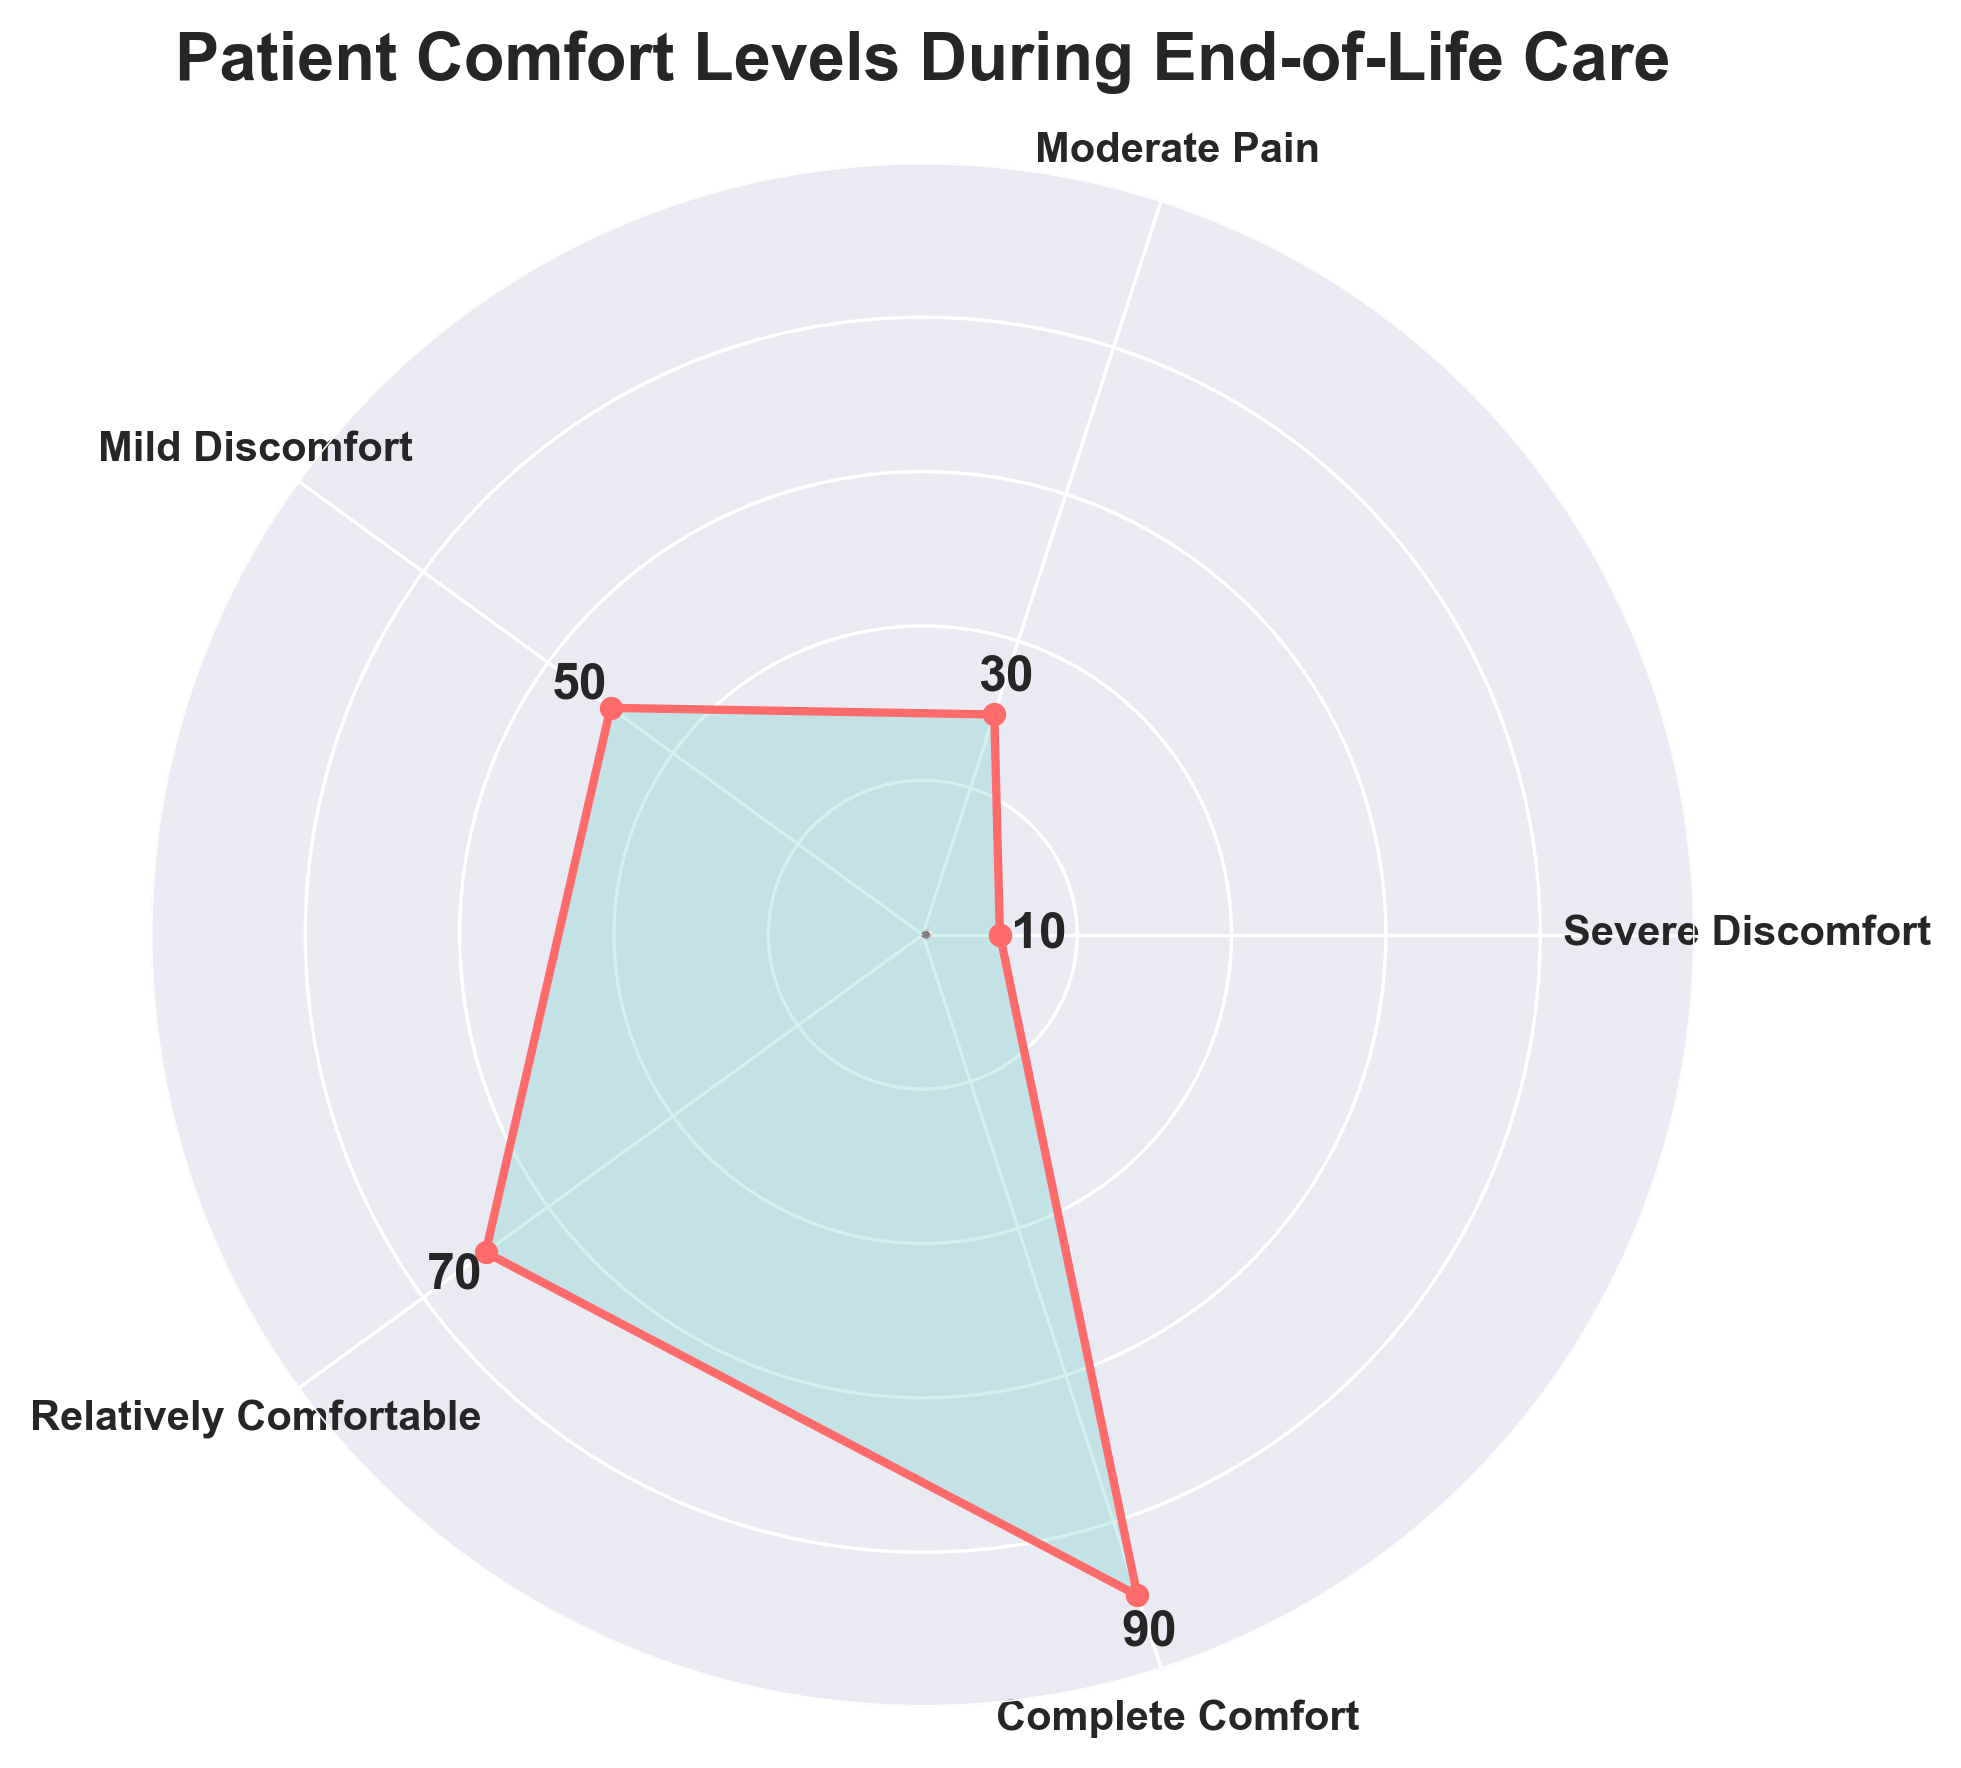What is the title of the figure? The title is usually located at or near the top of the figure. This one states "Patient Comfort Levels During End-of-Life Care".
Answer: Patient Comfort Levels During End-of-Life Care How many different comfort levels are displayed in the figure? Count the number of unique comfort levels indicated by text labels on the figure. There are five unique comfort levels.
Answer: 5 Which comfort level has the highest value? The value associated with each comfort level is displayed next to the labels. The highest value is associated with "Complete Comfort".
Answer: Complete Comfort What's the difference in value between "Severe Discomfort" and "Relatively Comfortable"? Locate the values for both "Severe Discomfort" and "Relatively Comfortable" and compute the difference. The values are 10 and 70, respectively, so the difference is 70 - 10.
Answer: 60 Which comfort level falls in the middle range of values? Organize the values to identify the middle: 10, 30, 50, 70, 90. "Mild Discomfort" is the middle value in this range.
Answer: Mild Discomfort What is the sum of the values of all comfort levels? Sum the individual values (10 + 30 + 50 + 70 + 90). The sum is 250.
Answer: 250 Which comfort level is just below "Complete Comfort” in value? Identify the value just below the highest value of 90. The next highest value is 70, corresponding to "Relatively Comfortable".
Answer: Relatively Comfortable What is the average value of all the comfort levels? To find the average, sum the values and divide by the number of levels: (10 + 30 + 50 + 70 + 90) / 5. The sum is 250, and the average is 250 / 5.
Answer: 50 